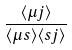<formula> <loc_0><loc_0><loc_500><loc_500>\frac { \langle \mu j \rangle } { \langle \mu s \rangle \langle s j \rangle }</formula> 